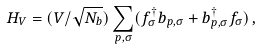<formula> <loc_0><loc_0><loc_500><loc_500>H _ { V } = ( V / \sqrt { N _ { b } } ) \sum _ { p , \sigma } ( f _ { \sigma } ^ { \dagger } b _ { p , \sigma } + b _ { p , \sigma } ^ { \dagger } f _ { \sigma } ) \, ,</formula> 